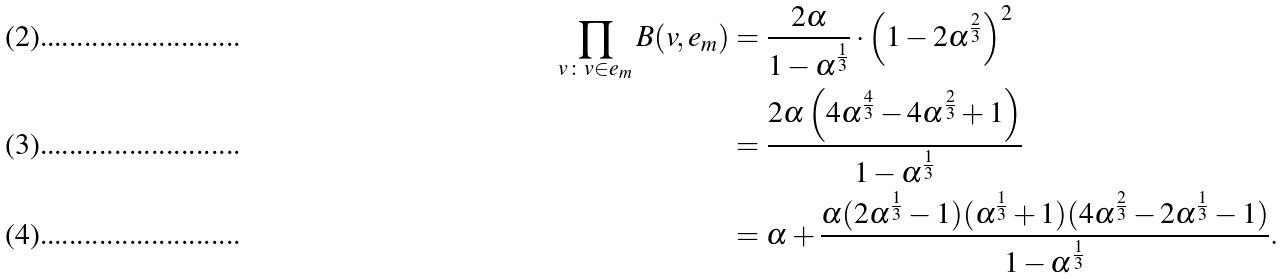Convert formula to latex. <formula><loc_0><loc_0><loc_500><loc_500>\prod _ { v \colon v \in e _ { m } } B ( v , e _ { m } ) & = \frac { 2 \alpha } { 1 - \alpha ^ { \frac { 1 } { 3 } } } \cdot \left ( 1 - 2 \alpha ^ { \frac { 2 } { 3 } } \right ) ^ { 2 } \\ & = \frac { 2 \alpha \left ( 4 \alpha ^ { \frac { 4 } { 3 } } - 4 \alpha ^ { \frac { 2 } { 3 } } + 1 \right ) } { 1 - \alpha ^ { \frac { 1 } { 3 } } } \\ & = \alpha + \frac { \alpha ( 2 \alpha ^ { \frac { 1 } { 3 } } - 1 ) ( \alpha ^ { \frac { 1 } { 3 } } + 1 ) ( 4 \alpha ^ { \frac { 2 } { 3 } } - 2 \alpha ^ { \frac { 1 } { 3 } } - 1 ) } { 1 - \alpha ^ { \frac { 1 } { 3 } } } .</formula> 